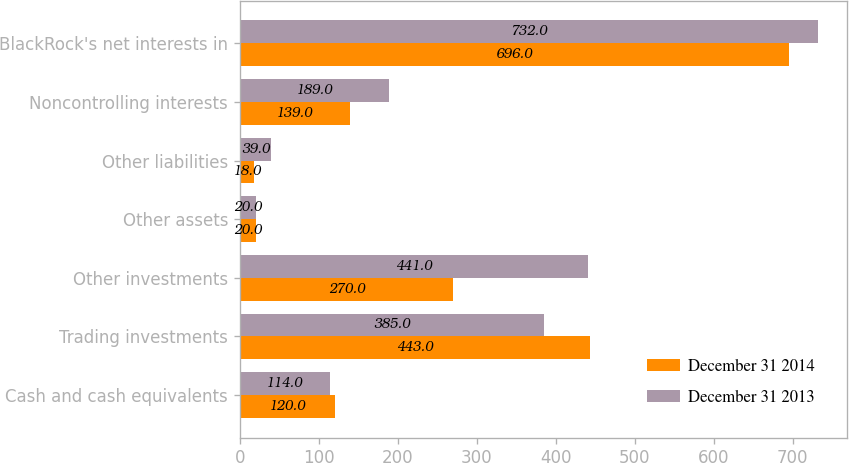Convert chart. <chart><loc_0><loc_0><loc_500><loc_500><stacked_bar_chart><ecel><fcel>Cash and cash equivalents<fcel>Trading investments<fcel>Other investments<fcel>Other assets<fcel>Other liabilities<fcel>Noncontrolling interests<fcel>BlackRock's net interests in<nl><fcel>December 31 2014<fcel>120<fcel>443<fcel>270<fcel>20<fcel>18<fcel>139<fcel>696<nl><fcel>December 31 2013<fcel>114<fcel>385<fcel>441<fcel>20<fcel>39<fcel>189<fcel>732<nl></chart> 